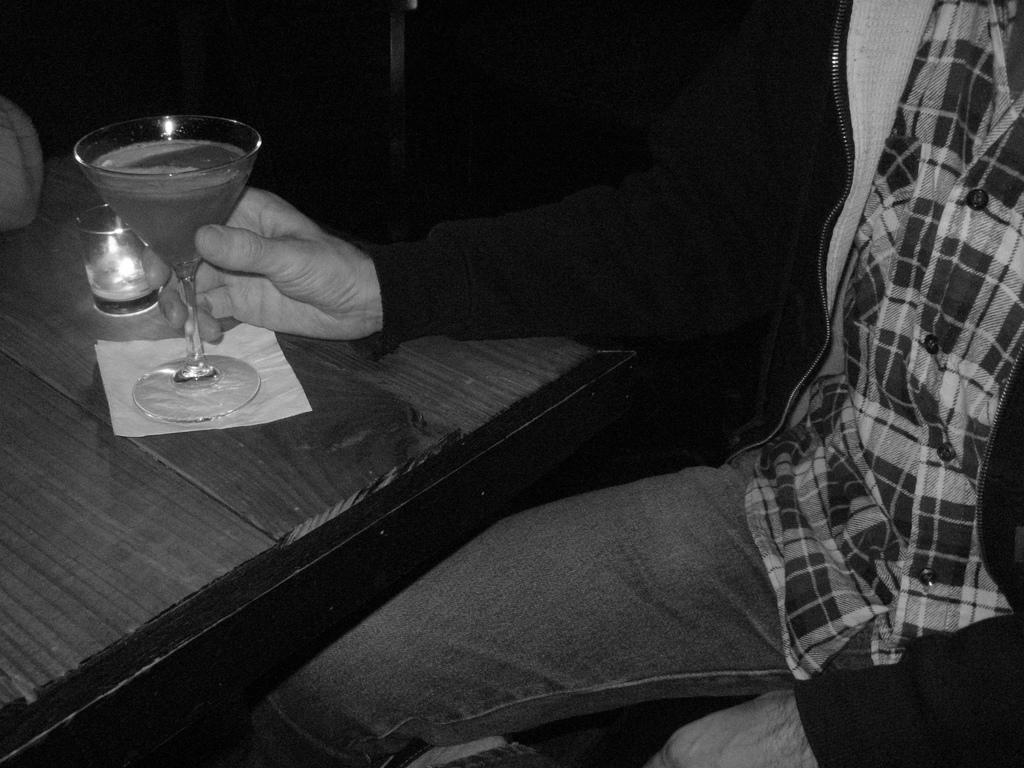Could you give a brief overview of what you see in this image? As we can see in the image there is a man holding glass and a table. 